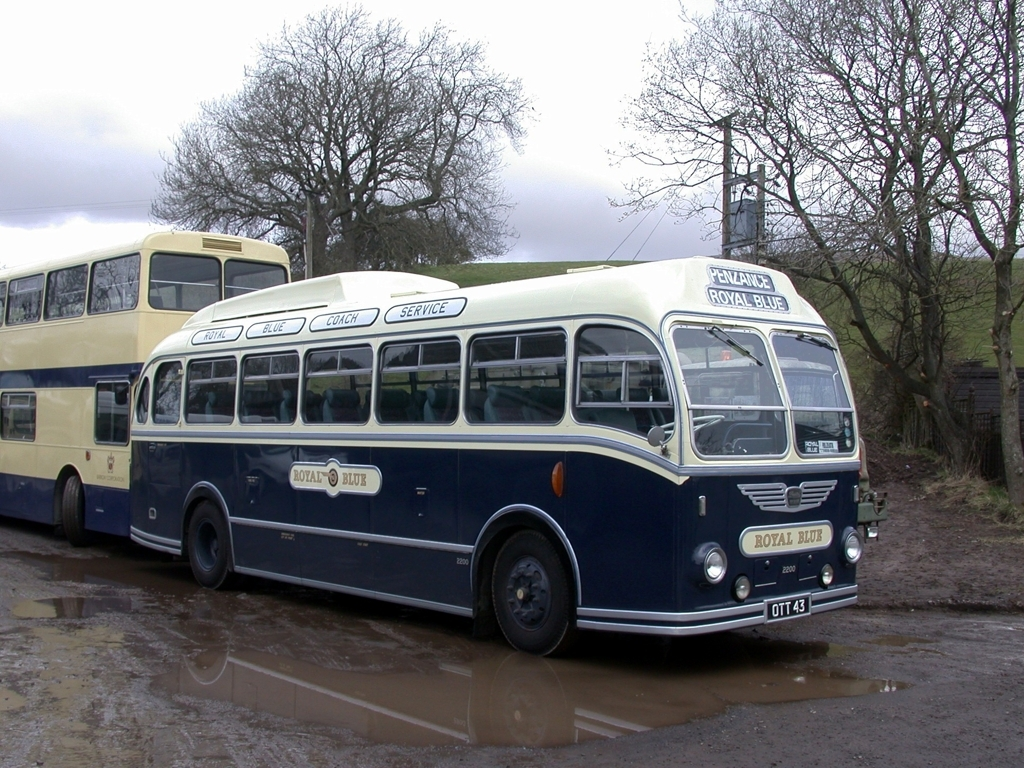What can we infer about the setting of this photograph? The setting appears to be a rural area, evidenced by the grassy fields and trees in the background, as well as the unpaved, puddle-strewn ground where the buses are parked. The lack of modern infrastructure reinforces the idea that this location might be a reserved space for showcasing or maintaining vintage vehicles, or it could be the site of an outdoor heritage event focusing on classic transportation. 